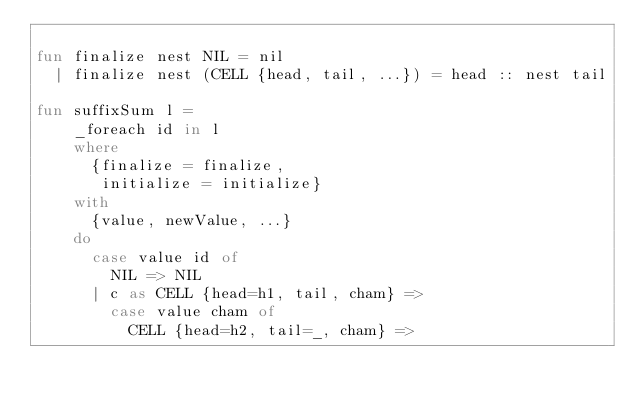<code> <loc_0><loc_0><loc_500><loc_500><_SML_>
fun finalize nest NIL = nil
  | finalize nest (CELL {head, tail, ...}) = head :: nest tail

fun suffixSum l =
    _foreach id in l
    where
      {finalize = finalize,
       initialize = initialize}
    with
      {value, newValue, ...}
    do
      case value id of
        NIL => NIL
      | c as CELL {head=h1, tail, cham} =>
        case value cham of
          CELL {head=h2, tail=_, cham} =></code> 